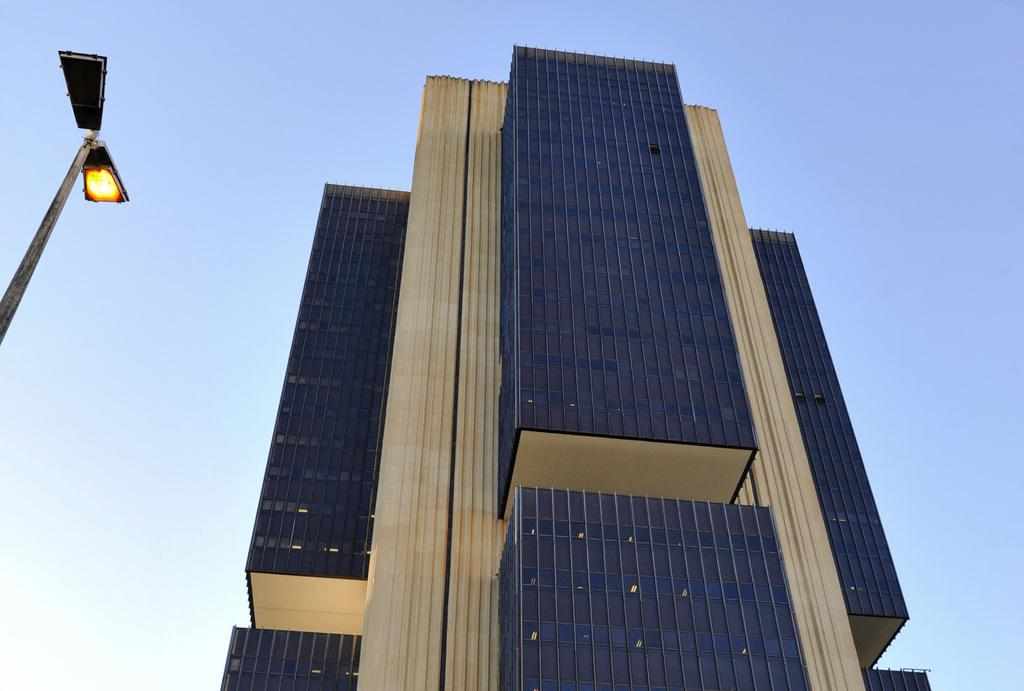Where was the picture taken? The picture was clicked outside. What can be seen on the left side of the image? There are lamps attached to a pole on the left side of the image. What is the main structure in the center of the image? There is a building in the center of the image. What is visible in the background of the image? The sky is visible in the background of the image. How many rabbits are hopping around the building in the image? There are no rabbits present in the image. What type of machine is used to print the sky in the background? The sky is a natural phenomenon and does not require a machine to be printed. 